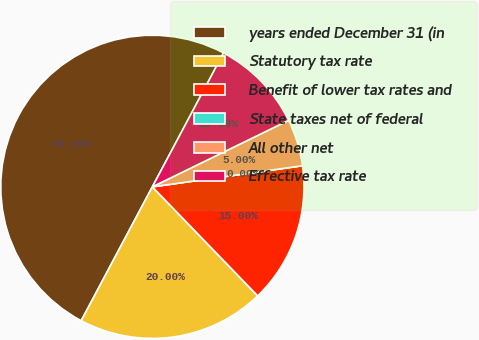Convert chart to OTSL. <chart><loc_0><loc_0><loc_500><loc_500><pie_chart><fcel>years ended December 31 (in<fcel>Statutory tax rate<fcel>Benefit of lower tax rates and<fcel>State taxes net of federal<fcel>All other net<fcel>Effective tax rate<nl><fcel>50.0%<fcel>20.0%<fcel>15.0%<fcel>0.0%<fcel>5.0%<fcel>10.0%<nl></chart> 